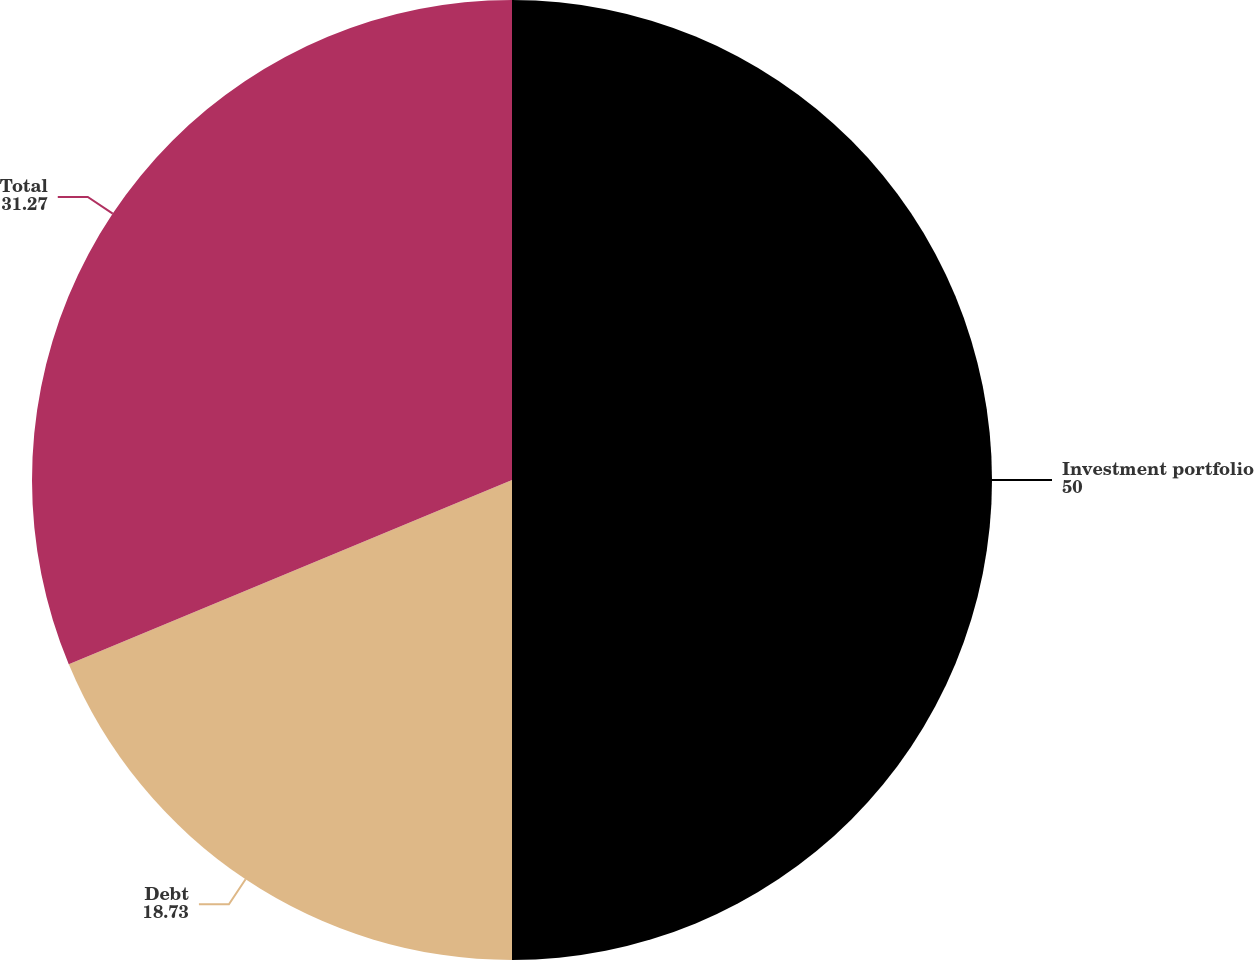<chart> <loc_0><loc_0><loc_500><loc_500><pie_chart><fcel>Investment portfolio<fcel>Debt<fcel>Total<nl><fcel>50.0%<fcel>18.73%<fcel>31.27%<nl></chart> 